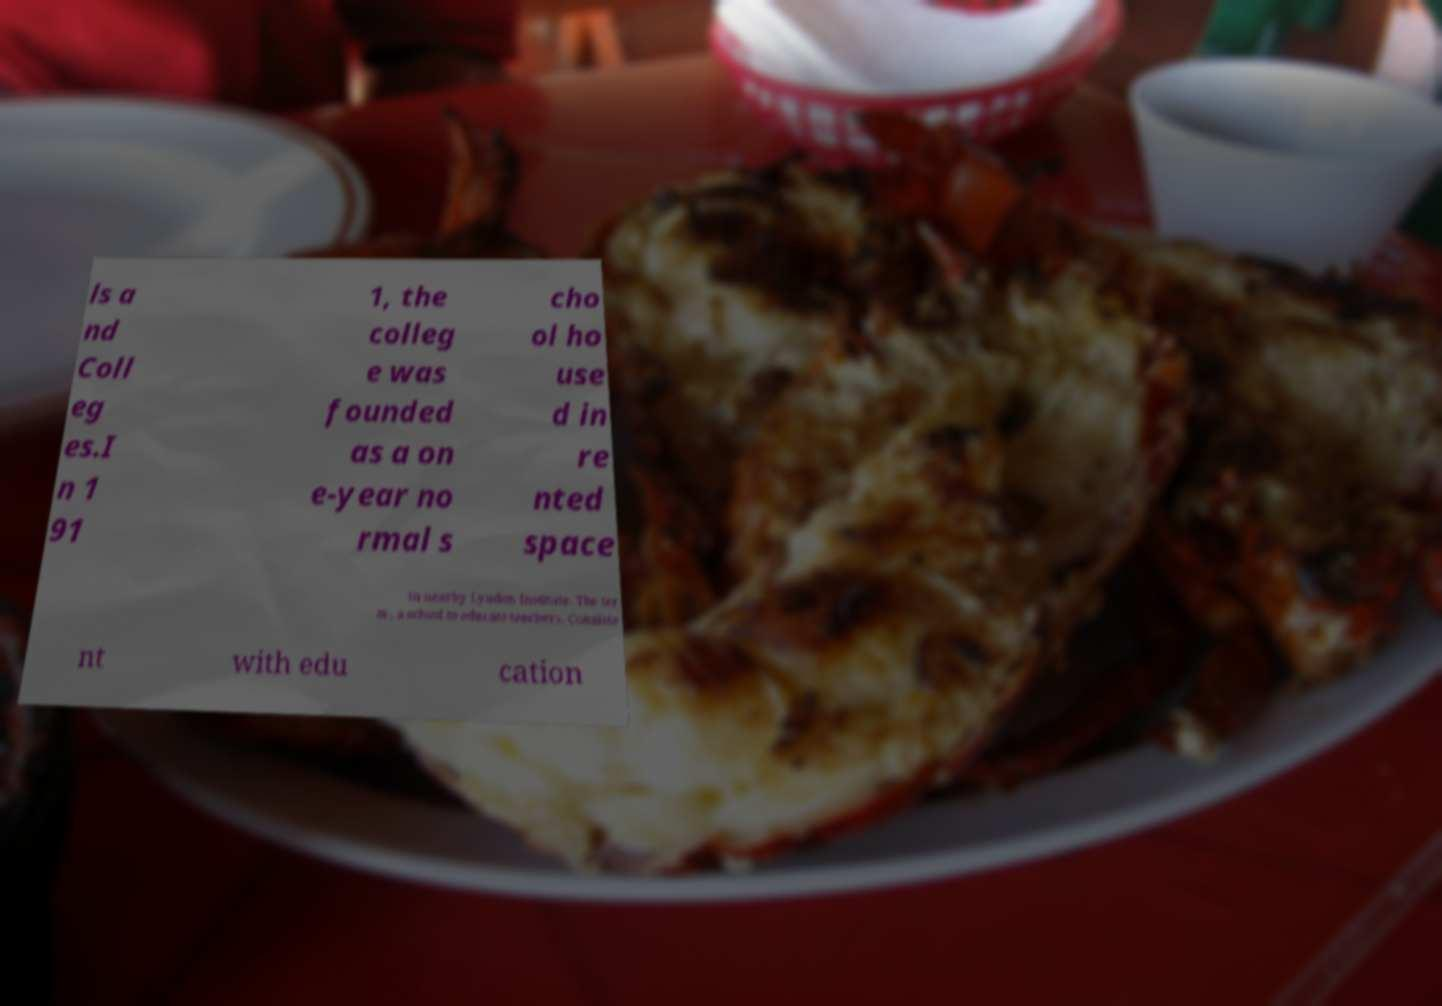Could you extract and type out the text from this image? ls a nd Coll eg es.I n 1 91 1, the colleg e was founded as a on e-year no rmal s cho ol ho use d in re nted space in nearby Lyndon Institute. The ter m , a school to educate teachers. Consiste nt with edu cation 